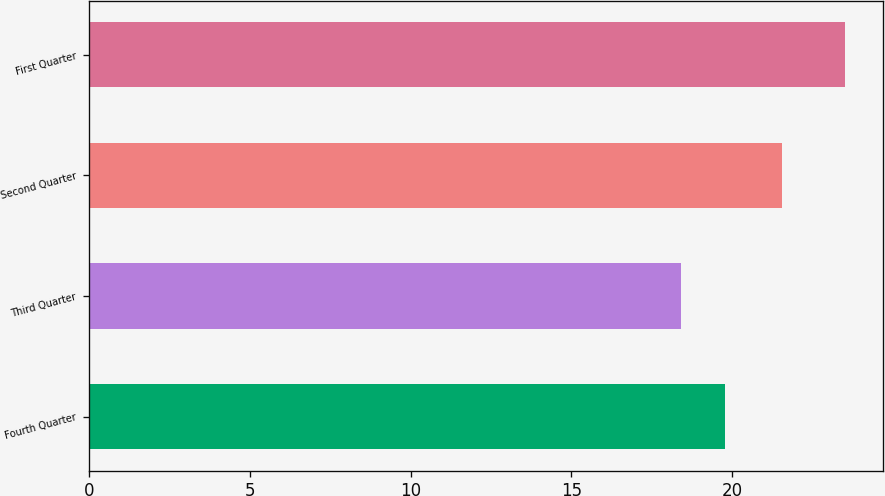Convert chart to OTSL. <chart><loc_0><loc_0><loc_500><loc_500><bar_chart><fcel>Fourth Quarter<fcel>Third Quarter<fcel>Second Quarter<fcel>First Quarter<nl><fcel>19.79<fcel>18.41<fcel>21.55<fcel>23.52<nl></chart> 